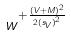<formula> <loc_0><loc_0><loc_500><loc_500>w ^ { + \frac { ( V + M ) ^ { 2 } } { 2 { ( s _ { V } ) } ^ { 2 } } }</formula> 